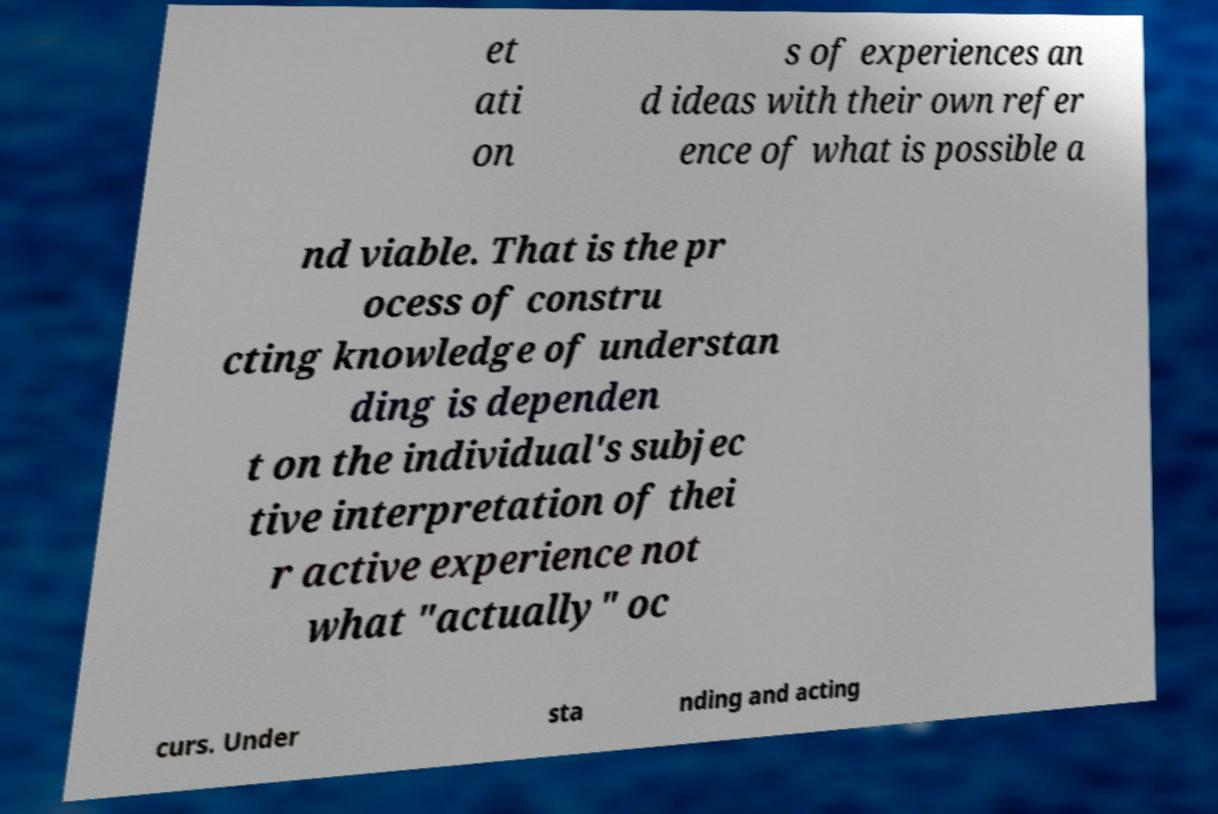There's text embedded in this image that I need extracted. Can you transcribe it verbatim? et ati on s of experiences an d ideas with their own refer ence of what is possible a nd viable. That is the pr ocess of constru cting knowledge of understan ding is dependen t on the individual's subjec tive interpretation of thei r active experience not what "actually" oc curs. Under sta nding and acting 